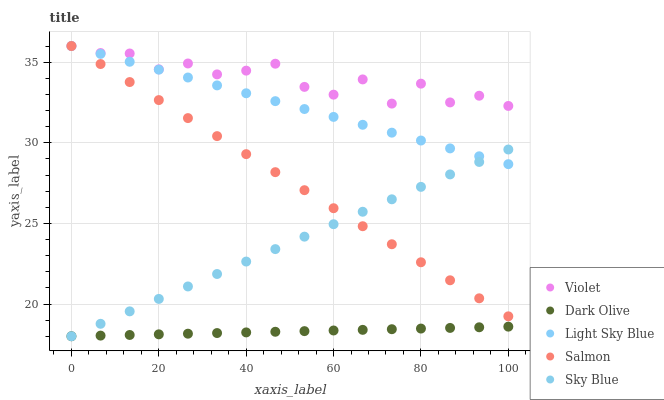Does Dark Olive have the minimum area under the curve?
Answer yes or no. Yes. Does Violet have the maximum area under the curve?
Answer yes or no. Yes. Does Salmon have the minimum area under the curve?
Answer yes or no. No. Does Salmon have the maximum area under the curve?
Answer yes or no. No. Is Light Sky Blue the smoothest?
Answer yes or no. Yes. Is Violet the roughest?
Answer yes or no. Yes. Is Dark Olive the smoothest?
Answer yes or no. No. Is Dark Olive the roughest?
Answer yes or no. No. Does Sky Blue have the lowest value?
Answer yes or no. Yes. Does Salmon have the lowest value?
Answer yes or no. No. Does Violet have the highest value?
Answer yes or no. Yes. Does Dark Olive have the highest value?
Answer yes or no. No. Is Sky Blue less than Violet?
Answer yes or no. Yes. Is Violet greater than Sky Blue?
Answer yes or no. Yes. Does Salmon intersect Sky Blue?
Answer yes or no. Yes. Is Salmon less than Sky Blue?
Answer yes or no. No. Is Salmon greater than Sky Blue?
Answer yes or no. No. Does Sky Blue intersect Violet?
Answer yes or no. No. 